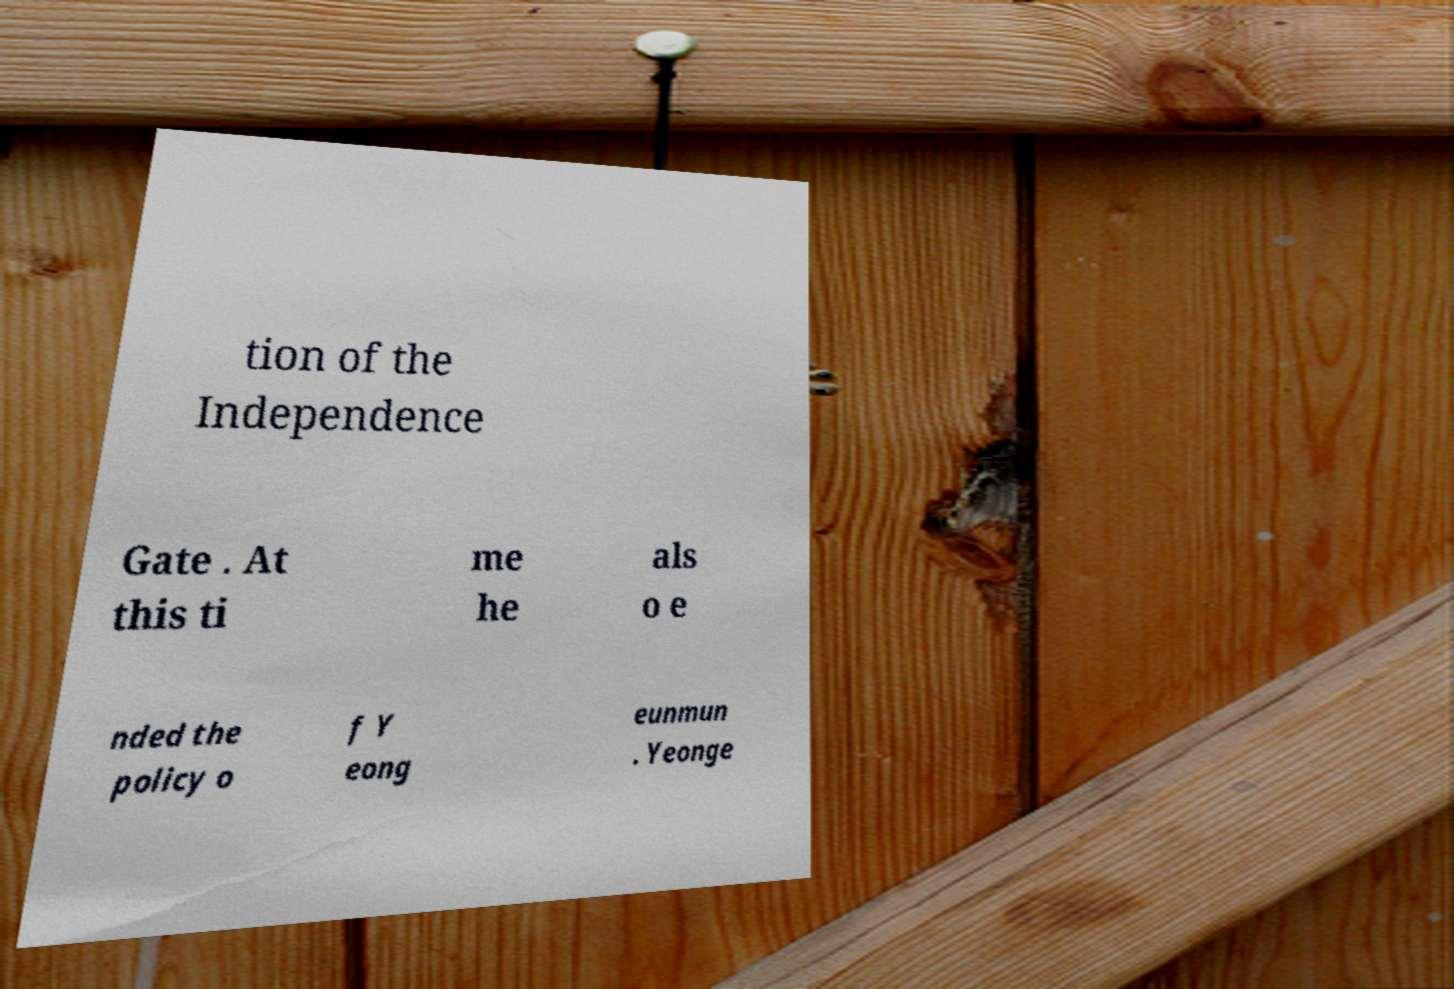What messages or text are displayed in this image? I need them in a readable, typed format. tion of the Independence Gate . At this ti me he als o e nded the policy o f Y eong eunmun . Yeonge 